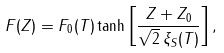<formula> <loc_0><loc_0><loc_500><loc_500>F ( Z ) = F _ { 0 } ( T ) \tanh \left [ \frac { Z + Z _ { 0 } } { \sqrt { 2 } \, \xi _ { S } ( T ) } \right ] ,</formula> 